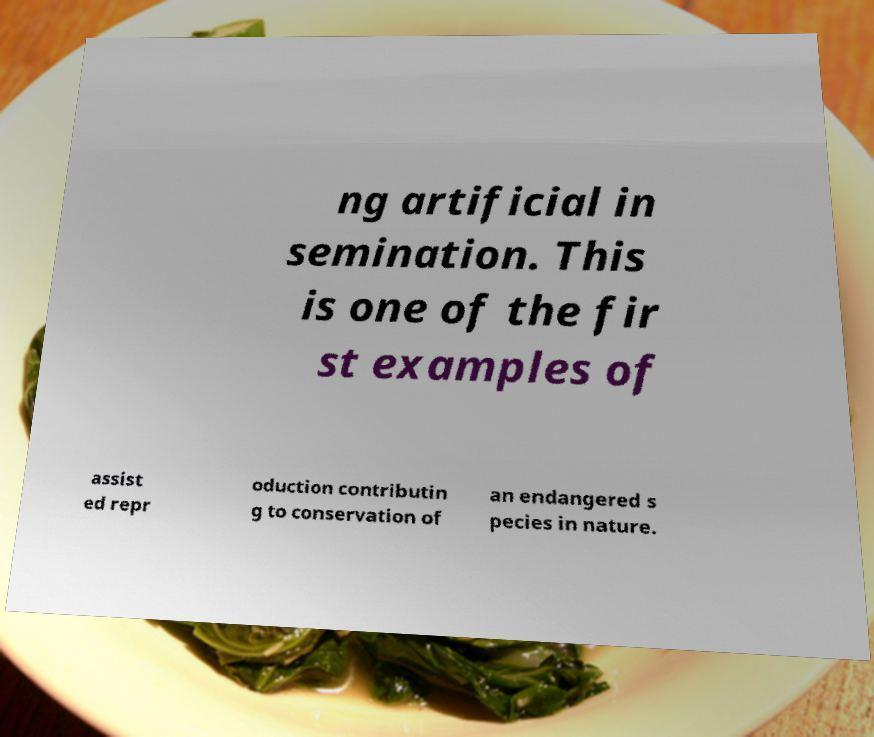Please read and relay the text visible in this image. What does it say? ng artificial in semination. This is one of the fir st examples of assist ed repr oduction contributin g to conservation of an endangered s pecies in nature. 